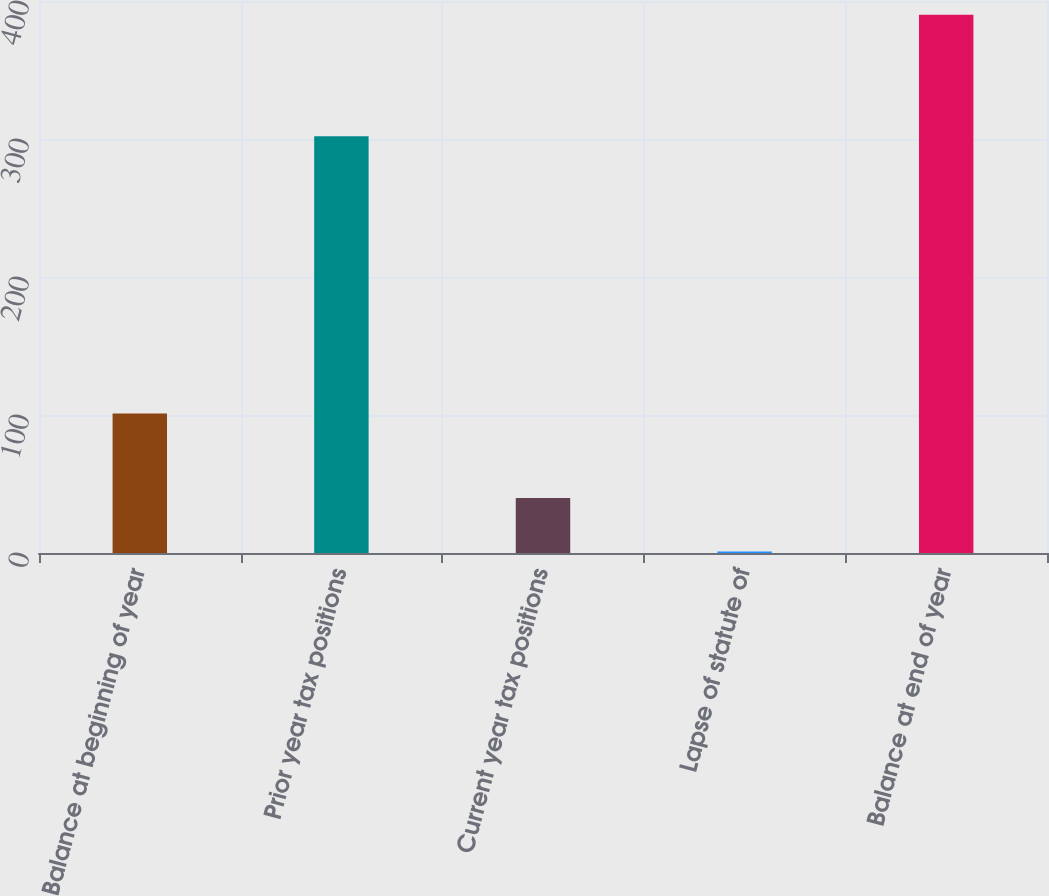<chart> <loc_0><loc_0><loc_500><loc_500><bar_chart><fcel>Balance at beginning of year<fcel>Prior year tax positions<fcel>Current year tax positions<fcel>Lapse of statute of<fcel>Balance at end of year<nl><fcel>101<fcel>302<fcel>39.9<fcel>1<fcel>390<nl></chart> 